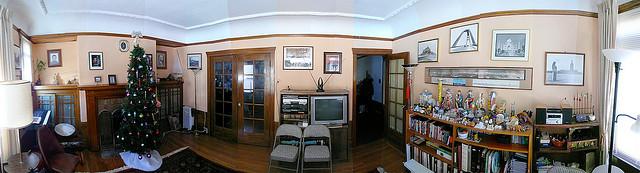How many framed pictures are on the wall?
Short answer required. 10. What holiday season is it?
Give a very brief answer. Christmas. What room is this?
Concise answer only. Living room. 